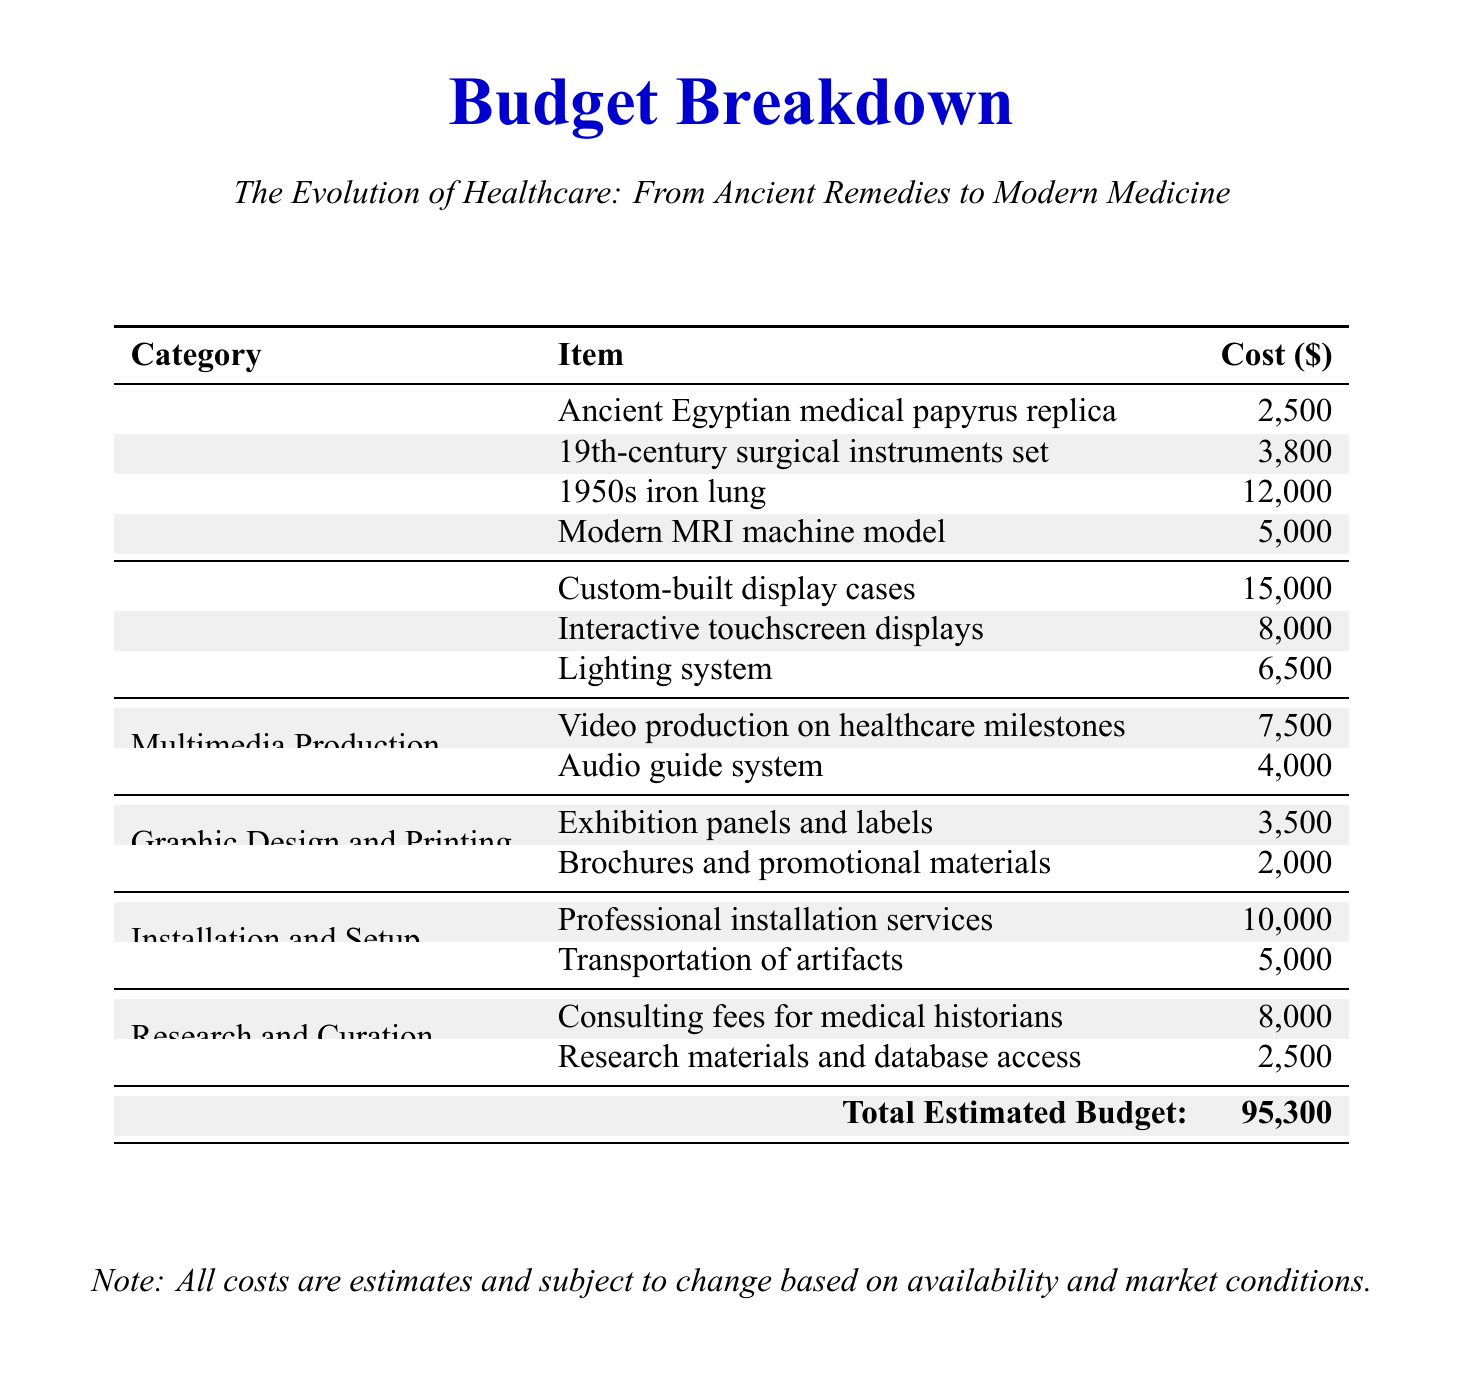What is the total estimated budget? The total estimated budget is presented at the bottom of the document, summing all costs listed.
Answer: 95,300 How much does the interactive touchscreen displays cost? The cost for interactive touchscreen displays is directly listed in the display design category of the document.
Answer: 8,000 What is the cost of the 1950s iron lung? The cost for the 1950s iron lung is explicitly mentioned under artifact acquisition.
Answer: 12,000 Who are the consultants for research and curation? The document references medical historians as consultants but does not list specific names.
Answer: medical historians What is the cost of professional installation services? This cost is provided as part of the installation and setup category in the budget table.
Answer: 10,000 What type of production is budgeted for healthcare milestones? The document specifies a type of multimedia production related to healthcare milestones.
Answer: Video production How many categories are there in the budget? By counting the categories listed in the document, we ascertain the total number.
Answer: 6 What is the cost of exhibition panels and labels? This cost is detailed in the graphic design and printing section of the budget.
Answer: 3,500 What item costs the most in the artifact acquisition section? The item with the highest cost in the artifact acquisition section is identified from the list provided in the budget.
Answer: 1950s iron lung 